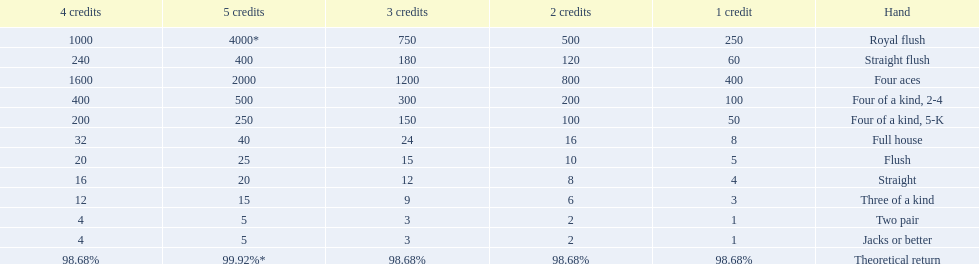Which hand is lower than straight flush? Four aces. Which hand is lower than four aces? Four of a kind, 2-4. Which hand is higher out of straight and flush? Flush. 